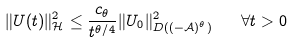<formula> <loc_0><loc_0><loc_500><loc_500>\| U ( t ) \| _ { \mathcal { H } } ^ { 2 } \leq \frac { c _ { \theta } } { t ^ { \theta / 4 } } \| U _ { 0 } \| _ { D ( ( - \mathcal { A } ) ^ { \theta } ) } ^ { 2 } \quad \forall t > 0</formula> 